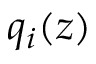<formula> <loc_0><loc_0><loc_500><loc_500>q _ { i } ( z )</formula> 